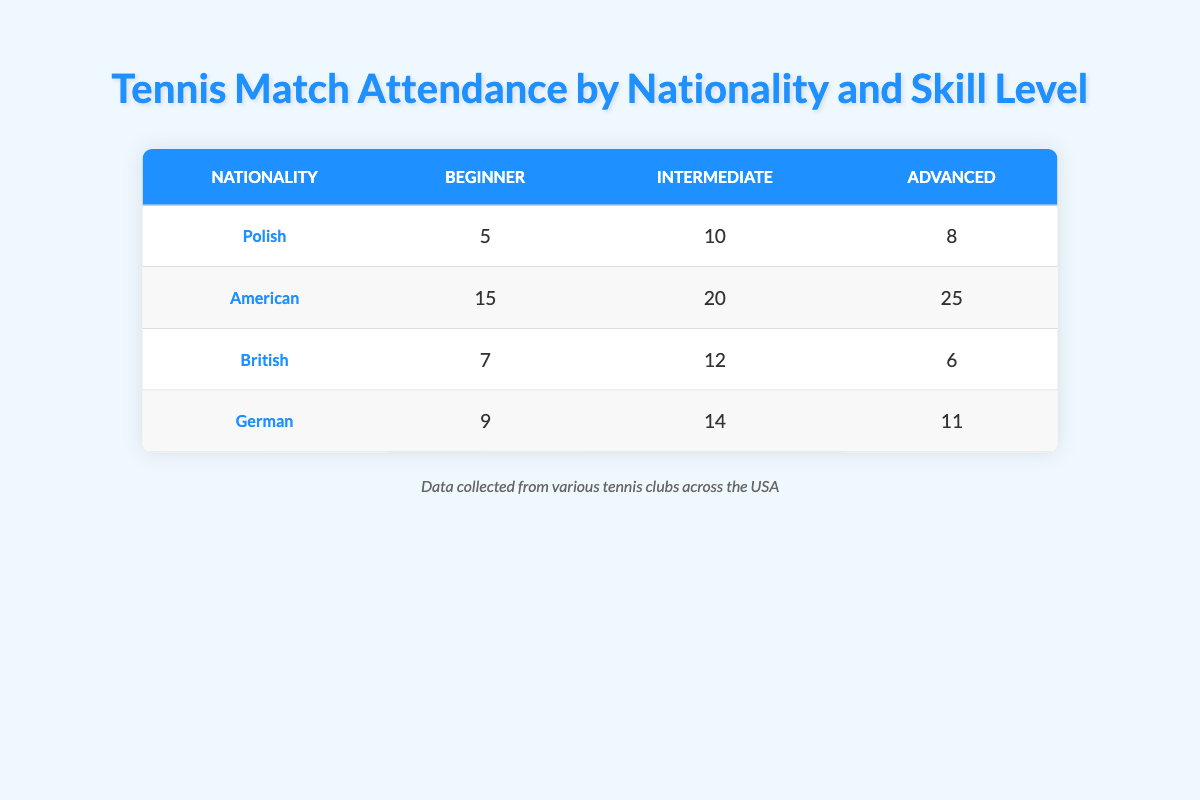What is the match attendance for Polish players at the beginner skill level? The table shows that Polish players have a match attendance of 5 at the beginner skill level.
Answer: 5 Which nationality has the highest number of match attendances at the intermediate skill level? By looking at the intermediate skill level column, American players have the highest match attendance with a total of 20.
Answer: American What is the total match attendance for British players across all skill levels? Adding the match attendances for British players: 7 (Beginner) + 12 (Intermediate) + 6 (Advanced) = 25.
Answer: 25 Is it true that German players attend more matches at the advanced skill level than Polish players? Checking the advanced skill level attendance, German players have 11 while Polish players have 8; thus, it is true.
Answer: Yes What is the average match attendance for American players? To find the average, add the match attendances: 15 (Beginner) + 20 (Intermediate) + 25 (Advanced) = 60. There are 3 data points, so the average is 60/3 = 20.
Answer: 20 How many more matches do American players attend at the advanced level compared to British players? The advanced level attendance for Americans is 25, and for British players, it is 6. The difference is 25 - 6 = 19.
Answer: 19 What is the median match attendance for players at the beginner skill level across all nationalities? The beginner skill level values are 5 (Polish), 15 (American), 7 (British), and 9 (German). When sorted: 5, 7, 9, 15. The median is the average of the two middle numbers (7 and 9), which is (7 + 9) / 2 = 8.
Answer: 8 Are British players more frequent attendees than Polish players at the intermediate skill level? British players have an attendance of 12 at the intermediate level, while Polish players have 10. Therefore, British players attend more matches.
Answer: Yes 